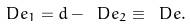<formula> <loc_0><loc_0><loc_500><loc_500>\ D e _ { 1 } = d - \ D e _ { 2 } \equiv \ D e .</formula> 